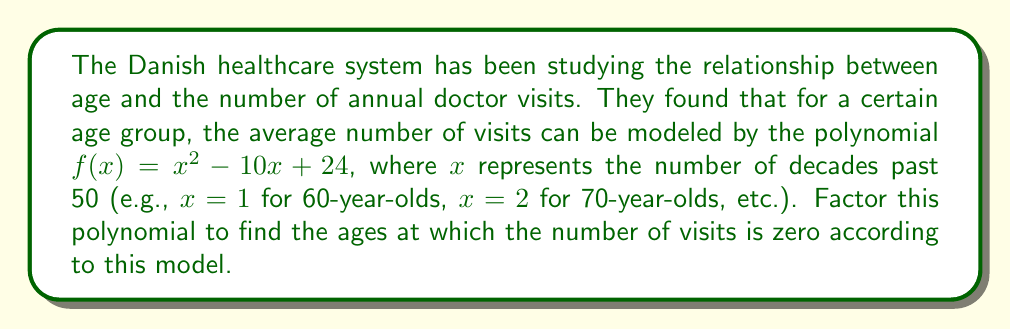Help me with this question. To factor this quadratic polynomial, we'll follow these steps:

1) Identify the polynomial: $f(x) = x^2 - 10x + 24$

2) This is in the standard form $ax^2 + bx + c$, where $a=1$, $b=-10$, and $c=24$

3) We'll use the quadratic formula to find the roots:
   $$x = \frac{-b \pm \sqrt{b^2 - 4ac}}{2a}$$

4) Substituting our values:
   $$x = \frac{10 \pm \sqrt{(-10)^2 - 4(1)(24)}}{2(1)}$$

5) Simplify:
   $$x = \frac{10 \pm \sqrt{100 - 96}}{2} = \frac{10 \pm \sqrt{4}}{2} = \frac{10 \pm 2}{2}$$

6) This gives us two solutions:
   $$x = \frac{10 + 2}{2} = 6$$ and $$x = \frac{10 - 2}{2} = 4$$

7) Therefore, the polynomial can be factored as:
   $$f(x) = (x - 4)(x - 6)$$

8) Interpreting the results:
   $x = 4$ means 4 decades past 50, which is 90 years old
   $x = 6$ means 6 decades past 50, which is 110 years old

Note: While these are the mathematical solutions, in reality, the number of doctor visits wouldn't be zero, and 110 years is beyond typical life expectancy. This highlights the limitations of the model.
Answer: $(x - 4)(x - 6)$ 